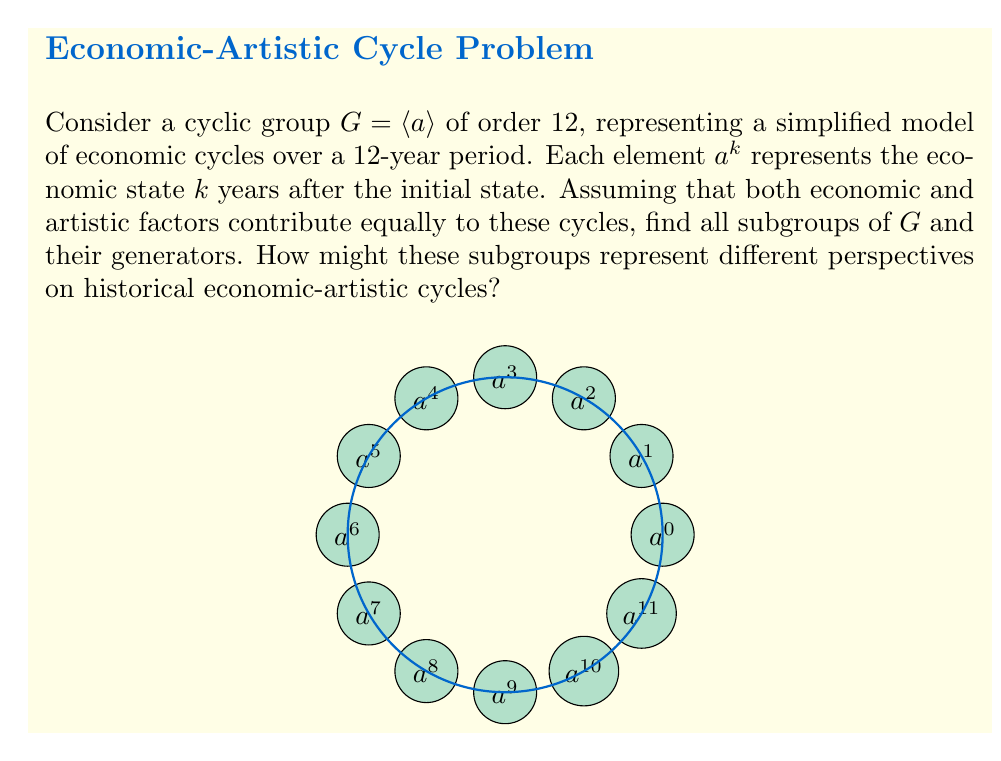What is the answer to this math problem? To find the subgroups of $G$, we need to consider the divisors of the group's order:

1) The divisors of 12 are 1, 2, 3, 4, 6, and 12.

2) For each divisor $d$, there is a unique subgroup of order $d$:

   - Order 1: $\{e\} = \{a^{12}\}$
   - Order 2: $\langle a^6 \rangle = \{e, a^6\}$
   - Order 3: $\langle a^4 \rangle = \{e, a^4, a^8\}$
   - Order 4: $\langle a^3 \rangle = \{e, a^3, a^6, a^9\}$
   - Order 6: $\langle a^2 \rangle = \{e, a^2, a^4, a^6, a^8, a^{10}\}$
   - Order 12: $G = \langle a \rangle = \{e, a, a^2, ..., a^{11}\}$

3) The generators for each subgroup are:
   - $\{e\}$: $e$
   - $\langle a^6 \rangle$: $a^6$
   - $\langle a^4 \rangle$: $a^4, a^8$
   - $\langle a^3 \rangle$: $a^3, a^9$
   - $\langle a^2 \rangle$: $a^2, a^4, a^8, a^{10}$
   - $G$: $a, a^5, a^7, a^{11}$

From an economic-artistic perspective:
- The subgroup of order 2 might represent a simplified view of economic-artistic cycles as either "boom" or "bust" periods.
- The subgroup of order 3 could represent a three-phase model of growth, stagnation, and decline in both economic and artistic domains.
- The subgroup of order 4 might correspond to seasonal patterns in economic activity and artistic production.
- The subgroup of order 6 could represent a more nuanced view of economic-artistic cycles, capturing biennial patterns.
Answer: Subgroups: $\{e\}$, $\langle a^6 \rangle$, $\langle a^4 \rangle$, $\langle a^3 \rangle$, $\langle a^2 \rangle$, $G$
Generators: $\{e\}$, $\{a^6\}$, $\{a^4, a^8\}$, $\{a^3, a^9\}$, $\{a^2, a^4, a^8, a^{10}\}$, $\{a, a^5, a^7, a^{11}\}$ 